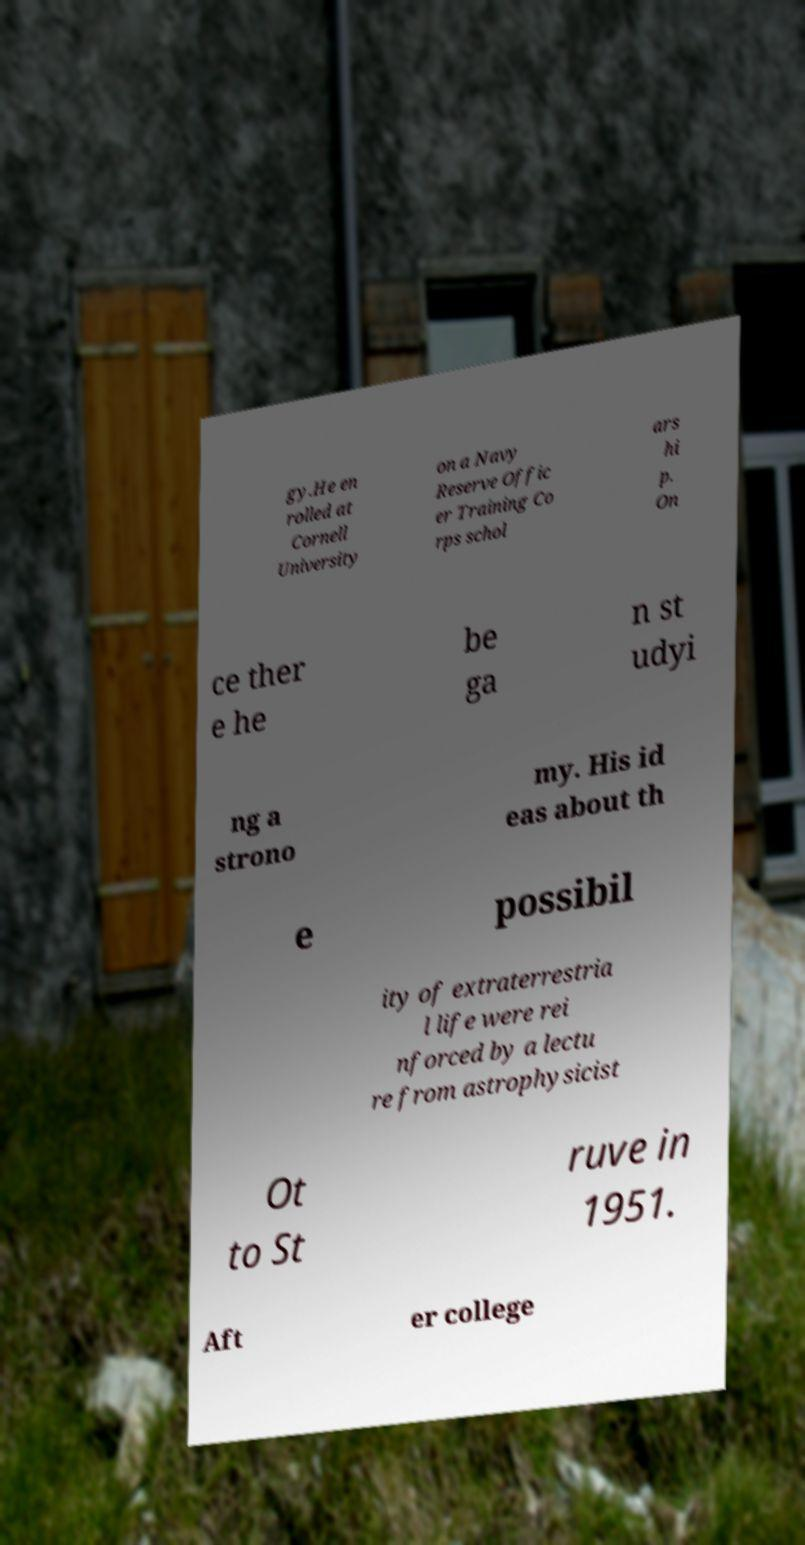Please read and relay the text visible in this image. What does it say? gy.He en rolled at Cornell University on a Navy Reserve Offic er Training Co rps schol ars hi p. On ce ther e he be ga n st udyi ng a strono my. His id eas about th e possibil ity of extraterrestria l life were rei nforced by a lectu re from astrophysicist Ot to St ruve in 1951. Aft er college 